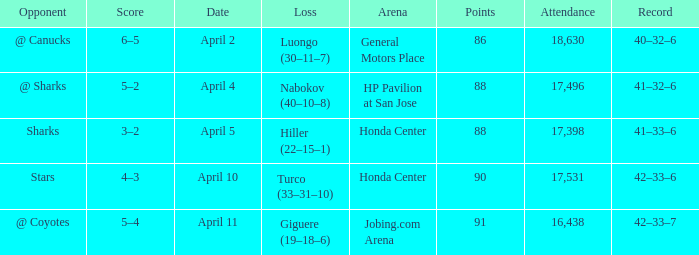Which score has a Loss of hiller (22–15–1)? 3–2. 